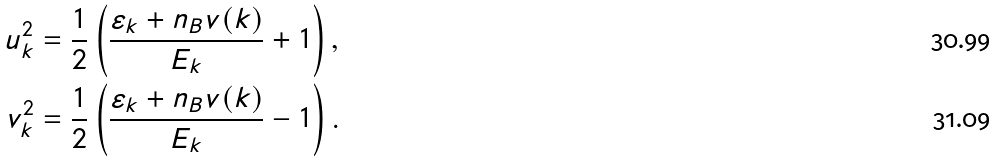<formula> <loc_0><loc_0><loc_500><loc_500>u _ { k } ^ { 2 } & = \frac { 1 } { 2 } \left ( \frac { \varepsilon _ { k } + n _ { B } v ( { k } ) } { E _ { k } } + 1 \right ) , \\ v _ { k } ^ { 2 } & = \frac { 1 } { 2 } \left ( \frac { \varepsilon _ { k } + n _ { B } v ( { k } ) } { E _ { k } } - 1 \right ) .</formula> 